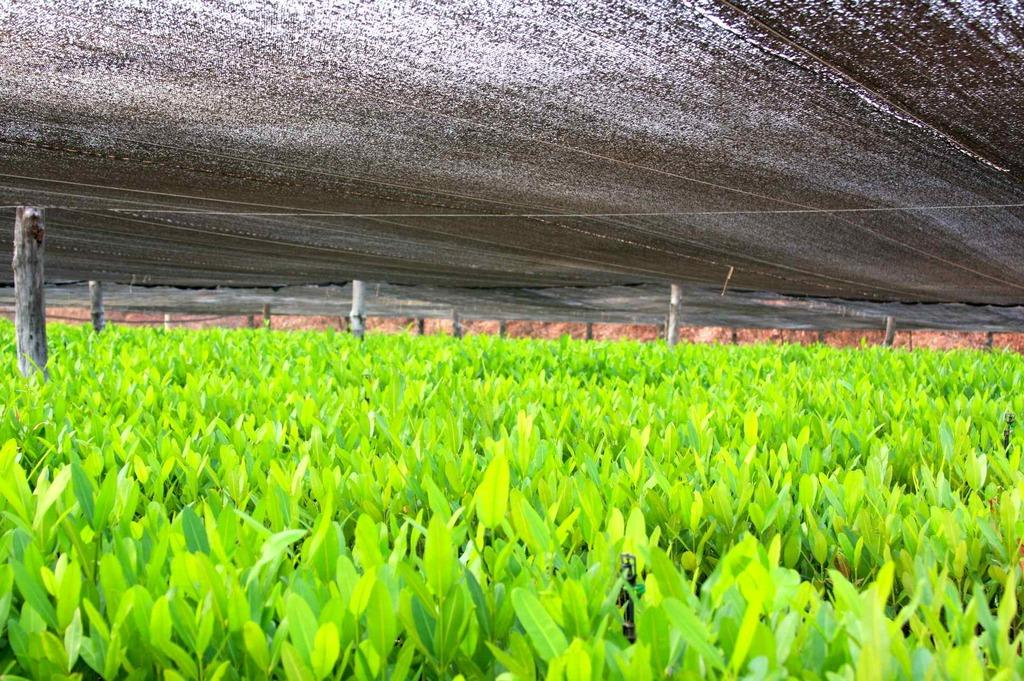What type of living organisms can be seen in the image? Plants can be seen in the image. What material are the poles made of in the image? The poles in the image are made of wood. What is visible at the top of the image? Sheets are visible at the top of the image. What type of vein is visible in the image? There is no vein present in the image. What type of clouds can be seen in the image? There are no clouds visible in the image. 